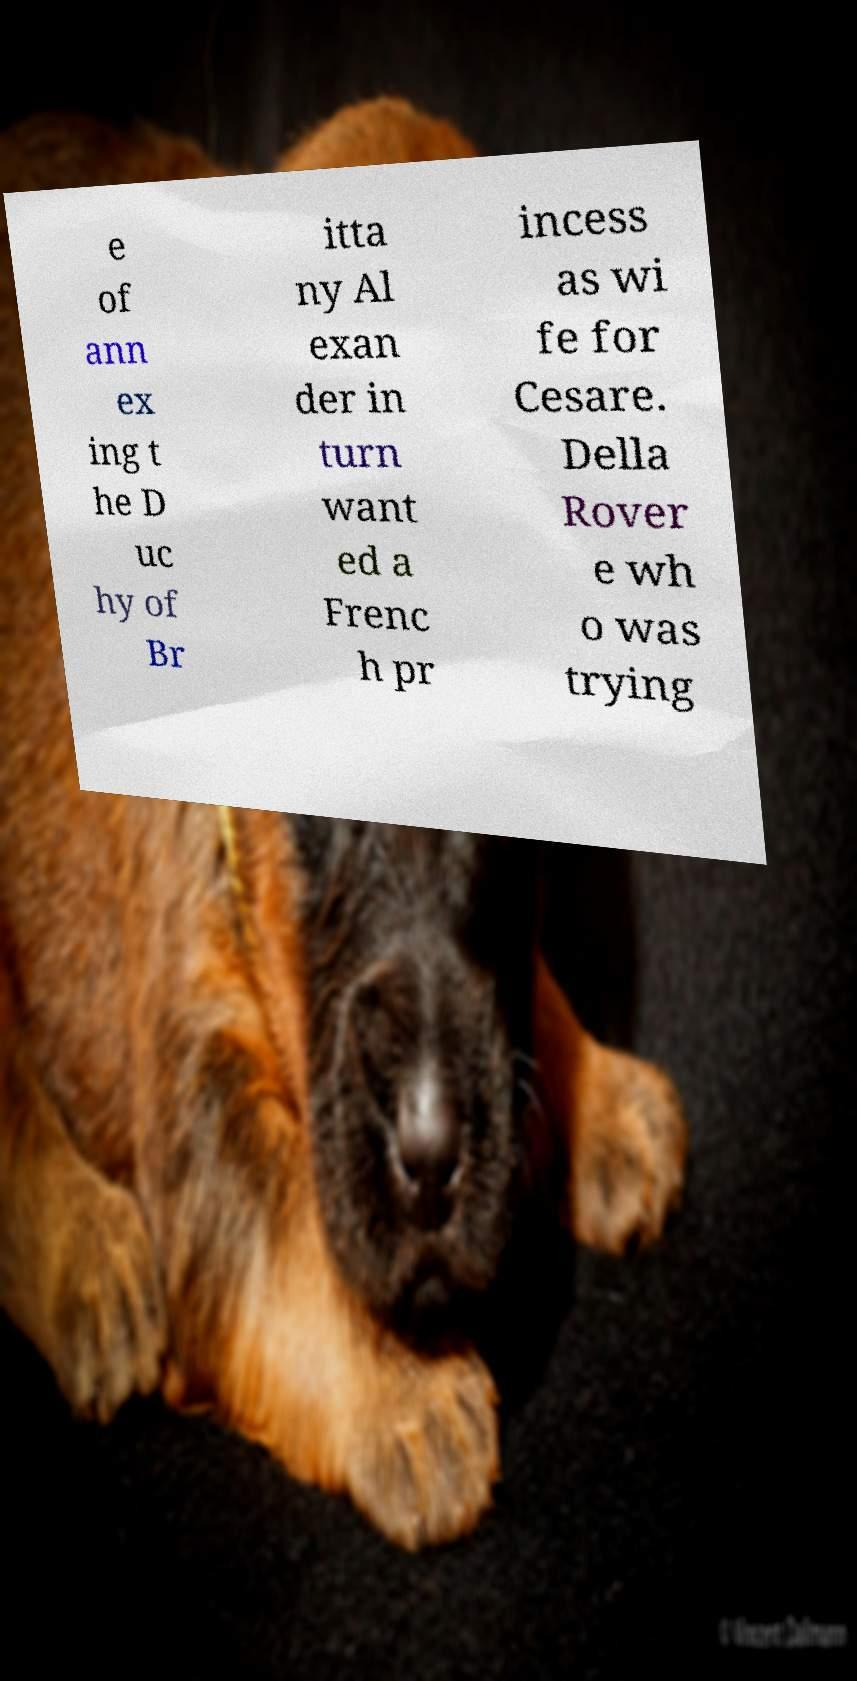Can you read and provide the text displayed in the image?This photo seems to have some interesting text. Can you extract and type it out for me? e of ann ex ing t he D uc hy of Br itta ny Al exan der in turn want ed a Frenc h pr incess as wi fe for Cesare. Della Rover e wh o was trying 